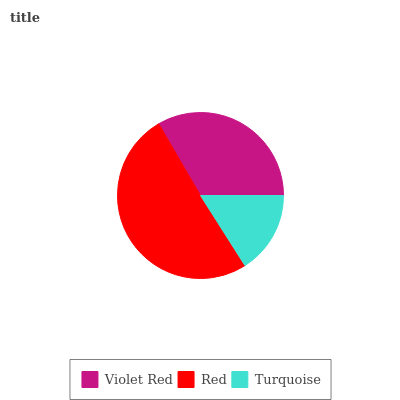Is Turquoise the minimum?
Answer yes or no. Yes. Is Red the maximum?
Answer yes or no. Yes. Is Red the minimum?
Answer yes or no. No. Is Turquoise the maximum?
Answer yes or no. No. Is Red greater than Turquoise?
Answer yes or no. Yes. Is Turquoise less than Red?
Answer yes or no. Yes. Is Turquoise greater than Red?
Answer yes or no. No. Is Red less than Turquoise?
Answer yes or no. No. Is Violet Red the high median?
Answer yes or no. Yes. Is Violet Red the low median?
Answer yes or no. Yes. Is Red the high median?
Answer yes or no. No. Is Red the low median?
Answer yes or no. No. 